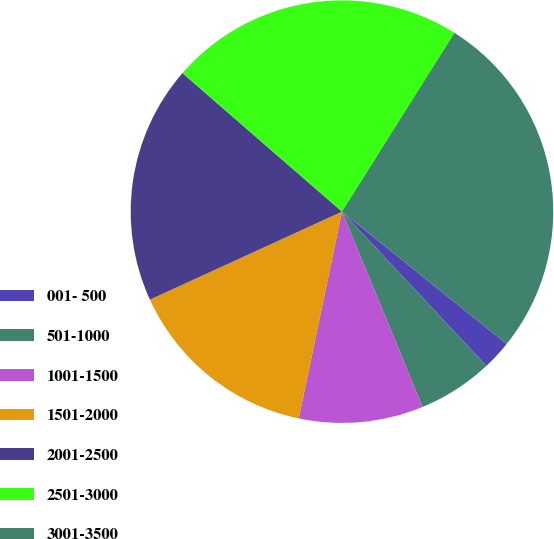Convert chart to OTSL. <chart><loc_0><loc_0><loc_500><loc_500><pie_chart><fcel>001- 500<fcel>501-1000<fcel>1001-1500<fcel>1501-2000<fcel>2001-2500<fcel>2501-3000<fcel>3001-3500<nl><fcel>2.25%<fcel>5.75%<fcel>9.51%<fcel>14.88%<fcel>18.22%<fcel>22.55%<fcel>26.84%<nl></chart> 